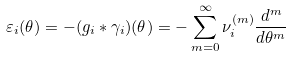Convert formula to latex. <formula><loc_0><loc_0><loc_500><loc_500>\varepsilon _ { i } ( \theta ) = - ( g _ { i } * \gamma _ { i } ) ( \theta ) = - \sum _ { m = 0 } ^ { \infty } \nu _ { i } ^ { ( m ) } \frac { d ^ { m } } { d \theta ^ { m } }</formula> 